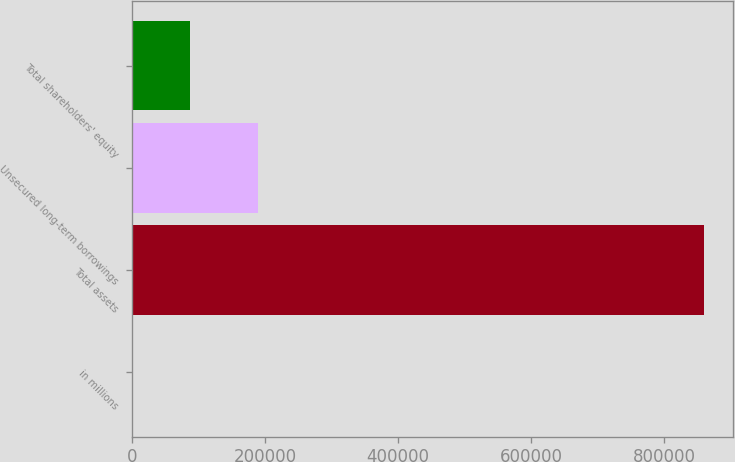Convert chart. <chart><loc_0><loc_0><loc_500><loc_500><bar_chart><fcel>in millions<fcel>Total assets<fcel>Unsecured long-term borrowings<fcel>Total shareholders' equity<nl><fcel>2016<fcel>860165<fcel>189086<fcel>87830.9<nl></chart> 